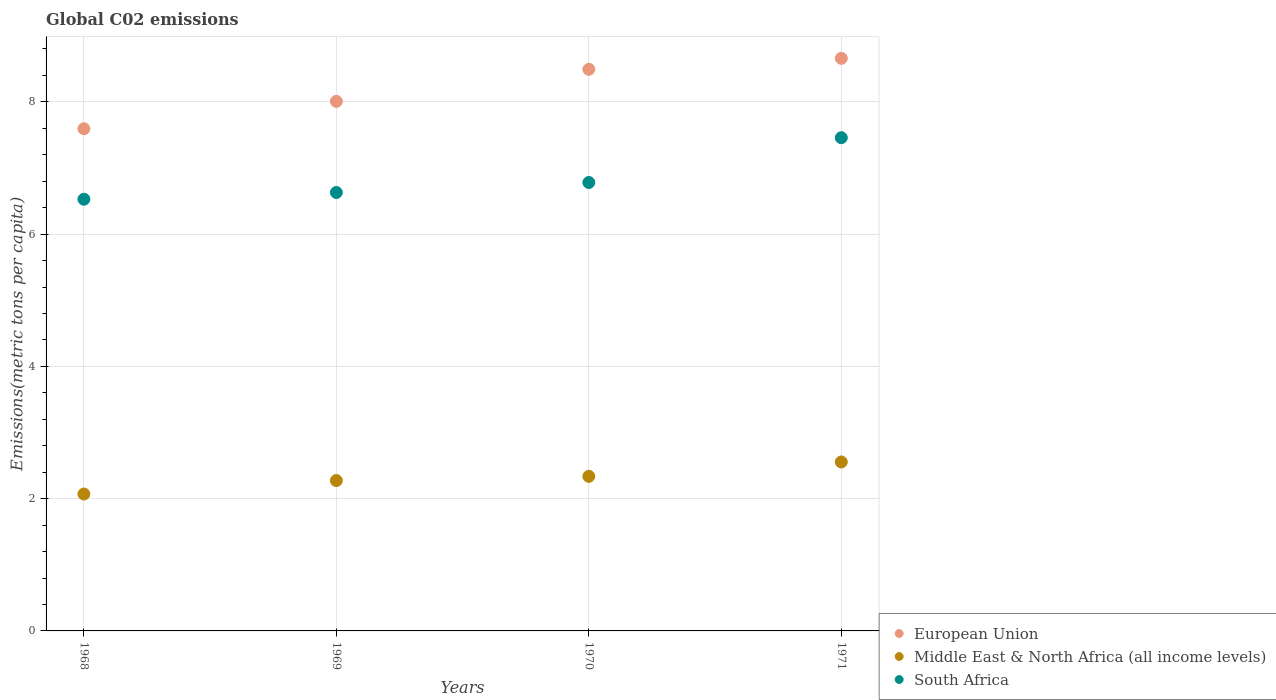Is the number of dotlines equal to the number of legend labels?
Offer a very short reply. Yes. What is the amount of CO2 emitted in in South Africa in 1971?
Offer a very short reply. 7.46. Across all years, what is the maximum amount of CO2 emitted in in South Africa?
Provide a succinct answer. 7.46. Across all years, what is the minimum amount of CO2 emitted in in South Africa?
Offer a very short reply. 6.53. In which year was the amount of CO2 emitted in in South Africa maximum?
Your response must be concise. 1971. In which year was the amount of CO2 emitted in in Middle East & North Africa (all income levels) minimum?
Give a very brief answer. 1968. What is the total amount of CO2 emitted in in South Africa in the graph?
Provide a succinct answer. 27.4. What is the difference between the amount of CO2 emitted in in European Union in 1969 and that in 1971?
Your response must be concise. -0.65. What is the difference between the amount of CO2 emitted in in Middle East & North Africa (all income levels) in 1971 and the amount of CO2 emitted in in South Africa in 1968?
Your answer should be compact. -3.97. What is the average amount of CO2 emitted in in European Union per year?
Offer a terse response. 8.19. In the year 1968, what is the difference between the amount of CO2 emitted in in European Union and amount of CO2 emitted in in Middle East & North Africa (all income levels)?
Make the answer very short. 5.52. In how many years, is the amount of CO2 emitted in in European Union greater than 2 metric tons per capita?
Make the answer very short. 4. What is the ratio of the amount of CO2 emitted in in European Union in 1968 to that in 1969?
Offer a terse response. 0.95. Is the amount of CO2 emitted in in European Union in 1969 less than that in 1970?
Your response must be concise. Yes. What is the difference between the highest and the second highest amount of CO2 emitted in in European Union?
Give a very brief answer. 0.17. What is the difference between the highest and the lowest amount of CO2 emitted in in South Africa?
Your answer should be very brief. 0.93. Does the amount of CO2 emitted in in European Union monotonically increase over the years?
Offer a terse response. Yes. Is the amount of CO2 emitted in in South Africa strictly greater than the amount of CO2 emitted in in European Union over the years?
Give a very brief answer. No. Is the amount of CO2 emitted in in Middle East & North Africa (all income levels) strictly less than the amount of CO2 emitted in in European Union over the years?
Your answer should be very brief. Yes. How many dotlines are there?
Your response must be concise. 3. What is the difference between two consecutive major ticks on the Y-axis?
Provide a short and direct response. 2. Does the graph contain grids?
Keep it short and to the point. Yes. Where does the legend appear in the graph?
Your answer should be compact. Bottom right. How many legend labels are there?
Offer a very short reply. 3. What is the title of the graph?
Give a very brief answer. Global C02 emissions. Does "Somalia" appear as one of the legend labels in the graph?
Provide a succinct answer. No. What is the label or title of the X-axis?
Your answer should be compact. Years. What is the label or title of the Y-axis?
Your answer should be very brief. Emissions(metric tons per capita). What is the Emissions(metric tons per capita) in European Union in 1968?
Keep it short and to the point. 7.59. What is the Emissions(metric tons per capita) in Middle East & North Africa (all income levels) in 1968?
Make the answer very short. 2.07. What is the Emissions(metric tons per capita) in South Africa in 1968?
Your response must be concise. 6.53. What is the Emissions(metric tons per capita) of European Union in 1969?
Offer a very short reply. 8.01. What is the Emissions(metric tons per capita) in Middle East & North Africa (all income levels) in 1969?
Keep it short and to the point. 2.27. What is the Emissions(metric tons per capita) of South Africa in 1969?
Your answer should be very brief. 6.63. What is the Emissions(metric tons per capita) in European Union in 1970?
Your response must be concise. 8.49. What is the Emissions(metric tons per capita) of Middle East & North Africa (all income levels) in 1970?
Offer a terse response. 2.34. What is the Emissions(metric tons per capita) of South Africa in 1970?
Keep it short and to the point. 6.78. What is the Emissions(metric tons per capita) in European Union in 1971?
Make the answer very short. 8.66. What is the Emissions(metric tons per capita) in Middle East & North Africa (all income levels) in 1971?
Keep it short and to the point. 2.55. What is the Emissions(metric tons per capita) of South Africa in 1971?
Give a very brief answer. 7.46. Across all years, what is the maximum Emissions(metric tons per capita) of European Union?
Provide a succinct answer. 8.66. Across all years, what is the maximum Emissions(metric tons per capita) of Middle East & North Africa (all income levels)?
Provide a short and direct response. 2.55. Across all years, what is the maximum Emissions(metric tons per capita) in South Africa?
Your response must be concise. 7.46. Across all years, what is the minimum Emissions(metric tons per capita) of European Union?
Provide a succinct answer. 7.59. Across all years, what is the minimum Emissions(metric tons per capita) of Middle East & North Africa (all income levels)?
Ensure brevity in your answer.  2.07. Across all years, what is the minimum Emissions(metric tons per capita) of South Africa?
Ensure brevity in your answer.  6.53. What is the total Emissions(metric tons per capita) of European Union in the graph?
Give a very brief answer. 32.75. What is the total Emissions(metric tons per capita) in Middle East & North Africa (all income levels) in the graph?
Ensure brevity in your answer.  9.24. What is the total Emissions(metric tons per capita) of South Africa in the graph?
Your answer should be compact. 27.4. What is the difference between the Emissions(metric tons per capita) in European Union in 1968 and that in 1969?
Give a very brief answer. -0.41. What is the difference between the Emissions(metric tons per capita) in Middle East & North Africa (all income levels) in 1968 and that in 1969?
Give a very brief answer. -0.2. What is the difference between the Emissions(metric tons per capita) of South Africa in 1968 and that in 1969?
Your answer should be very brief. -0.1. What is the difference between the Emissions(metric tons per capita) in European Union in 1968 and that in 1970?
Make the answer very short. -0.9. What is the difference between the Emissions(metric tons per capita) of Middle East & North Africa (all income levels) in 1968 and that in 1970?
Your answer should be compact. -0.27. What is the difference between the Emissions(metric tons per capita) in South Africa in 1968 and that in 1970?
Your answer should be compact. -0.25. What is the difference between the Emissions(metric tons per capita) in European Union in 1968 and that in 1971?
Offer a very short reply. -1.06. What is the difference between the Emissions(metric tons per capita) of Middle East & North Africa (all income levels) in 1968 and that in 1971?
Your response must be concise. -0.48. What is the difference between the Emissions(metric tons per capita) of South Africa in 1968 and that in 1971?
Make the answer very short. -0.93. What is the difference between the Emissions(metric tons per capita) of European Union in 1969 and that in 1970?
Give a very brief answer. -0.48. What is the difference between the Emissions(metric tons per capita) in Middle East & North Africa (all income levels) in 1969 and that in 1970?
Provide a succinct answer. -0.06. What is the difference between the Emissions(metric tons per capita) of South Africa in 1969 and that in 1970?
Your response must be concise. -0.15. What is the difference between the Emissions(metric tons per capita) in European Union in 1969 and that in 1971?
Your answer should be very brief. -0.65. What is the difference between the Emissions(metric tons per capita) in Middle East & North Africa (all income levels) in 1969 and that in 1971?
Give a very brief answer. -0.28. What is the difference between the Emissions(metric tons per capita) of South Africa in 1969 and that in 1971?
Keep it short and to the point. -0.83. What is the difference between the Emissions(metric tons per capita) in European Union in 1970 and that in 1971?
Make the answer very short. -0.17. What is the difference between the Emissions(metric tons per capita) of Middle East & North Africa (all income levels) in 1970 and that in 1971?
Keep it short and to the point. -0.22. What is the difference between the Emissions(metric tons per capita) in South Africa in 1970 and that in 1971?
Your response must be concise. -0.68. What is the difference between the Emissions(metric tons per capita) of European Union in 1968 and the Emissions(metric tons per capita) of Middle East & North Africa (all income levels) in 1969?
Your answer should be very brief. 5.32. What is the difference between the Emissions(metric tons per capita) in European Union in 1968 and the Emissions(metric tons per capita) in South Africa in 1969?
Give a very brief answer. 0.96. What is the difference between the Emissions(metric tons per capita) in Middle East & North Africa (all income levels) in 1968 and the Emissions(metric tons per capita) in South Africa in 1969?
Your answer should be very brief. -4.56. What is the difference between the Emissions(metric tons per capita) of European Union in 1968 and the Emissions(metric tons per capita) of Middle East & North Africa (all income levels) in 1970?
Your answer should be very brief. 5.26. What is the difference between the Emissions(metric tons per capita) in European Union in 1968 and the Emissions(metric tons per capita) in South Africa in 1970?
Offer a very short reply. 0.81. What is the difference between the Emissions(metric tons per capita) of Middle East & North Africa (all income levels) in 1968 and the Emissions(metric tons per capita) of South Africa in 1970?
Provide a succinct answer. -4.71. What is the difference between the Emissions(metric tons per capita) of European Union in 1968 and the Emissions(metric tons per capita) of Middle East & North Africa (all income levels) in 1971?
Provide a short and direct response. 5.04. What is the difference between the Emissions(metric tons per capita) of European Union in 1968 and the Emissions(metric tons per capita) of South Africa in 1971?
Provide a succinct answer. 0.14. What is the difference between the Emissions(metric tons per capita) of Middle East & North Africa (all income levels) in 1968 and the Emissions(metric tons per capita) of South Africa in 1971?
Provide a short and direct response. -5.39. What is the difference between the Emissions(metric tons per capita) in European Union in 1969 and the Emissions(metric tons per capita) in Middle East & North Africa (all income levels) in 1970?
Provide a succinct answer. 5.67. What is the difference between the Emissions(metric tons per capita) in European Union in 1969 and the Emissions(metric tons per capita) in South Africa in 1970?
Your answer should be compact. 1.23. What is the difference between the Emissions(metric tons per capita) in Middle East & North Africa (all income levels) in 1969 and the Emissions(metric tons per capita) in South Africa in 1970?
Offer a very short reply. -4.51. What is the difference between the Emissions(metric tons per capita) in European Union in 1969 and the Emissions(metric tons per capita) in Middle East & North Africa (all income levels) in 1971?
Your response must be concise. 5.45. What is the difference between the Emissions(metric tons per capita) of European Union in 1969 and the Emissions(metric tons per capita) of South Africa in 1971?
Provide a succinct answer. 0.55. What is the difference between the Emissions(metric tons per capita) in Middle East & North Africa (all income levels) in 1969 and the Emissions(metric tons per capita) in South Africa in 1971?
Your response must be concise. -5.18. What is the difference between the Emissions(metric tons per capita) in European Union in 1970 and the Emissions(metric tons per capita) in Middle East & North Africa (all income levels) in 1971?
Keep it short and to the point. 5.94. What is the difference between the Emissions(metric tons per capita) in European Union in 1970 and the Emissions(metric tons per capita) in South Africa in 1971?
Ensure brevity in your answer.  1.03. What is the difference between the Emissions(metric tons per capita) in Middle East & North Africa (all income levels) in 1970 and the Emissions(metric tons per capita) in South Africa in 1971?
Your answer should be very brief. -5.12. What is the average Emissions(metric tons per capita) in European Union per year?
Offer a terse response. 8.19. What is the average Emissions(metric tons per capita) in Middle East & North Africa (all income levels) per year?
Offer a very short reply. 2.31. What is the average Emissions(metric tons per capita) in South Africa per year?
Ensure brevity in your answer.  6.85. In the year 1968, what is the difference between the Emissions(metric tons per capita) in European Union and Emissions(metric tons per capita) in Middle East & North Africa (all income levels)?
Give a very brief answer. 5.52. In the year 1968, what is the difference between the Emissions(metric tons per capita) of European Union and Emissions(metric tons per capita) of South Africa?
Give a very brief answer. 1.07. In the year 1968, what is the difference between the Emissions(metric tons per capita) in Middle East & North Africa (all income levels) and Emissions(metric tons per capita) in South Africa?
Ensure brevity in your answer.  -4.46. In the year 1969, what is the difference between the Emissions(metric tons per capita) of European Union and Emissions(metric tons per capita) of Middle East & North Africa (all income levels)?
Offer a terse response. 5.73. In the year 1969, what is the difference between the Emissions(metric tons per capita) in European Union and Emissions(metric tons per capita) in South Africa?
Offer a terse response. 1.38. In the year 1969, what is the difference between the Emissions(metric tons per capita) of Middle East & North Africa (all income levels) and Emissions(metric tons per capita) of South Africa?
Your answer should be compact. -4.36. In the year 1970, what is the difference between the Emissions(metric tons per capita) of European Union and Emissions(metric tons per capita) of Middle East & North Africa (all income levels)?
Your response must be concise. 6.15. In the year 1970, what is the difference between the Emissions(metric tons per capita) in European Union and Emissions(metric tons per capita) in South Africa?
Provide a succinct answer. 1.71. In the year 1970, what is the difference between the Emissions(metric tons per capita) of Middle East & North Africa (all income levels) and Emissions(metric tons per capita) of South Africa?
Your answer should be very brief. -4.44. In the year 1971, what is the difference between the Emissions(metric tons per capita) in European Union and Emissions(metric tons per capita) in Middle East & North Africa (all income levels)?
Ensure brevity in your answer.  6.1. In the year 1971, what is the difference between the Emissions(metric tons per capita) of European Union and Emissions(metric tons per capita) of South Africa?
Ensure brevity in your answer.  1.2. In the year 1971, what is the difference between the Emissions(metric tons per capita) in Middle East & North Africa (all income levels) and Emissions(metric tons per capita) in South Africa?
Provide a short and direct response. -4.9. What is the ratio of the Emissions(metric tons per capita) in European Union in 1968 to that in 1969?
Keep it short and to the point. 0.95. What is the ratio of the Emissions(metric tons per capita) of Middle East & North Africa (all income levels) in 1968 to that in 1969?
Your response must be concise. 0.91. What is the ratio of the Emissions(metric tons per capita) of South Africa in 1968 to that in 1969?
Provide a short and direct response. 0.98. What is the ratio of the Emissions(metric tons per capita) in European Union in 1968 to that in 1970?
Provide a short and direct response. 0.89. What is the ratio of the Emissions(metric tons per capita) of Middle East & North Africa (all income levels) in 1968 to that in 1970?
Ensure brevity in your answer.  0.89. What is the ratio of the Emissions(metric tons per capita) in South Africa in 1968 to that in 1970?
Offer a terse response. 0.96. What is the ratio of the Emissions(metric tons per capita) in European Union in 1968 to that in 1971?
Offer a terse response. 0.88. What is the ratio of the Emissions(metric tons per capita) in Middle East & North Africa (all income levels) in 1968 to that in 1971?
Your answer should be very brief. 0.81. What is the ratio of the Emissions(metric tons per capita) in South Africa in 1968 to that in 1971?
Make the answer very short. 0.88. What is the ratio of the Emissions(metric tons per capita) in European Union in 1969 to that in 1970?
Provide a succinct answer. 0.94. What is the ratio of the Emissions(metric tons per capita) in Middle East & North Africa (all income levels) in 1969 to that in 1970?
Your answer should be compact. 0.97. What is the ratio of the Emissions(metric tons per capita) in South Africa in 1969 to that in 1970?
Provide a short and direct response. 0.98. What is the ratio of the Emissions(metric tons per capita) in European Union in 1969 to that in 1971?
Your answer should be compact. 0.92. What is the ratio of the Emissions(metric tons per capita) in Middle East & North Africa (all income levels) in 1969 to that in 1971?
Your answer should be compact. 0.89. What is the ratio of the Emissions(metric tons per capita) in South Africa in 1969 to that in 1971?
Ensure brevity in your answer.  0.89. What is the ratio of the Emissions(metric tons per capita) of European Union in 1970 to that in 1971?
Your answer should be very brief. 0.98. What is the ratio of the Emissions(metric tons per capita) of Middle East & North Africa (all income levels) in 1970 to that in 1971?
Give a very brief answer. 0.91. What is the ratio of the Emissions(metric tons per capita) of South Africa in 1970 to that in 1971?
Provide a succinct answer. 0.91. What is the difference between the highest and the second highest Emissions(metric tons per capita) of European Union?
Your answer should be very brief. 0.17. What is the difference between the highest and the second highest Emissions(metric tons per capita) in Middle East & North Africa (all income levels)?
Offer a terse response. 0.22. What is the difference between the highest and the second highest Emissions(metric tons per capita) in South Africa?
Make the answer very short. 0.68. What is the difference between the highest and the lowest Emissions(metric tons per capita) in European Union?
Provide a succinct answer. 1.06. What is the difference between the highest and the lowest Emissions(metric tons per capita) in Middle East & North Africa (all income levels)?
Your answer should be compact. 0.48. What is the difference between the highest and the lowest Emissions(metric tons per capita) in South Africa?
Ensure brevity in your answer.  0.93. 